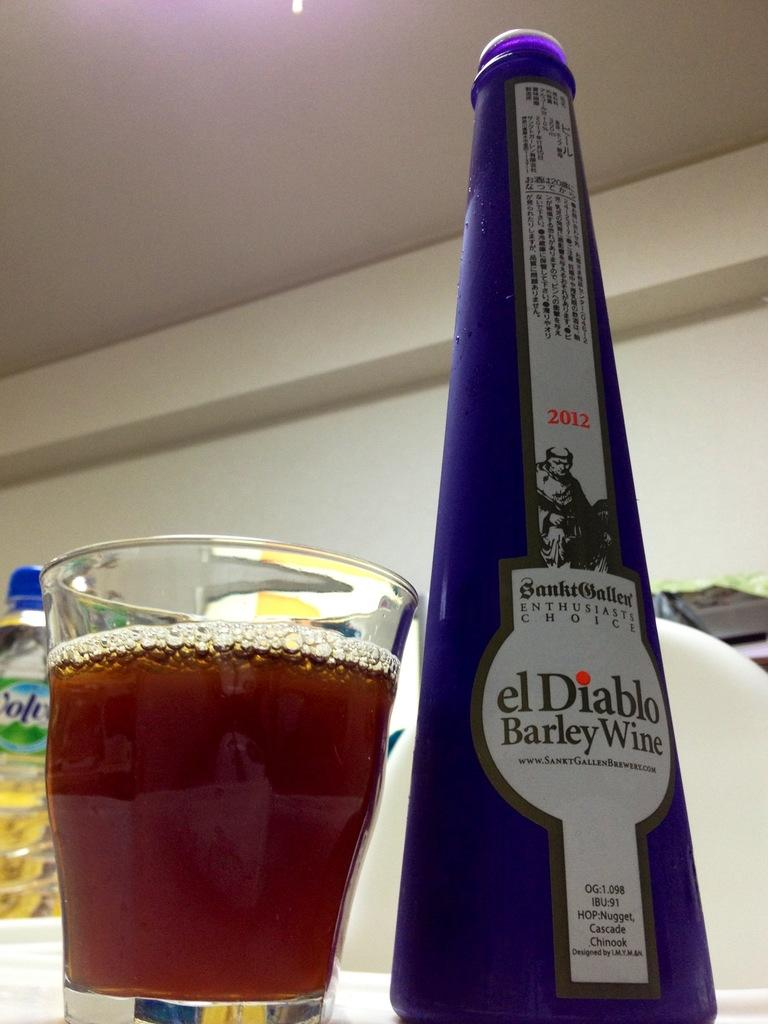<image>
Share a concise interpretation of the image provided. An opened bottle of El Diablo Barley Wine sits next to a glass of wine. 